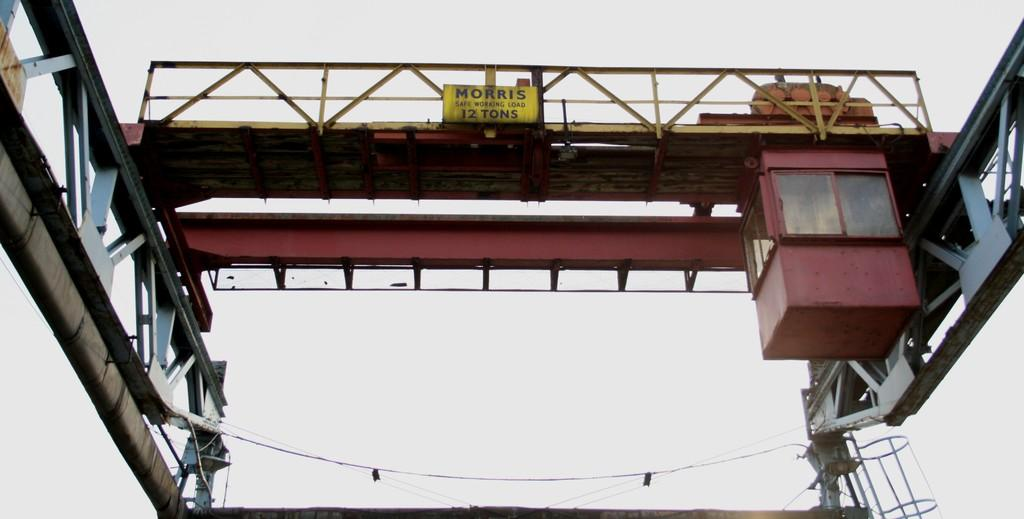What type of structure can be seen in the image? There is a bridge in the image. What else can be seen in the image besides the bridge? There are wires visible in the image. Is there any other object or feature in the image? Yes, there is a board in the image. Who is the owner of the sofa in the image? There is no sofa present in the image. 